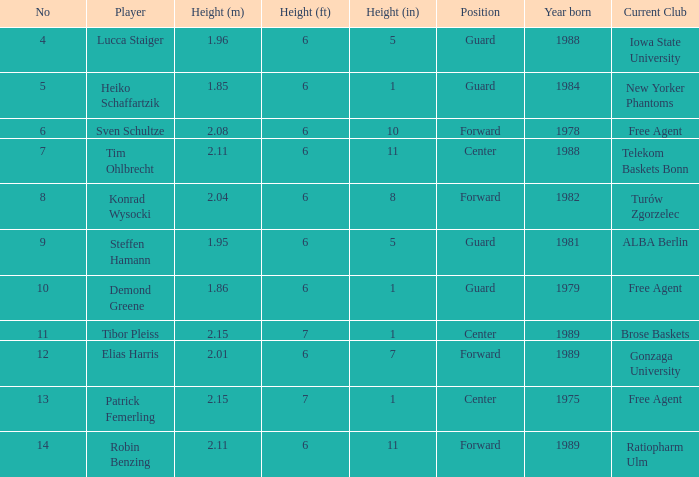Name the player that is 1.85 m Heiko Schaffartzik. 